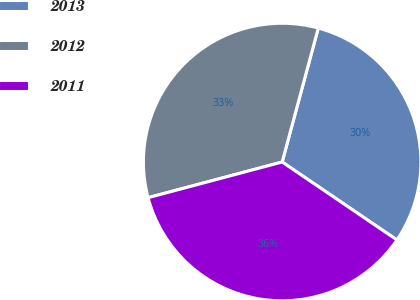Convert chart to OTSL. <chart><loc_0><loc_0><loc_500><loc_500><pie_chart><fcel>2013<fcel>2012<fcel>2011<nl><fcel>30.3%<fcel>33.33%<fcel>36.36%<nl></chart> 